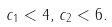<formula> <loc_0><loc_0><loc_500><loc_500>c _ { 1 } < 4 , \, c _ { 2 } < 6 .</formula> 